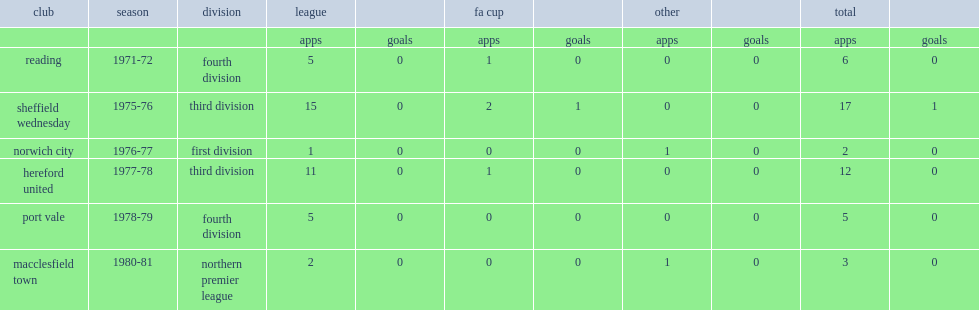How many games did andy proudlove for norwich city play first division game in the 1976-77? 1.0. 